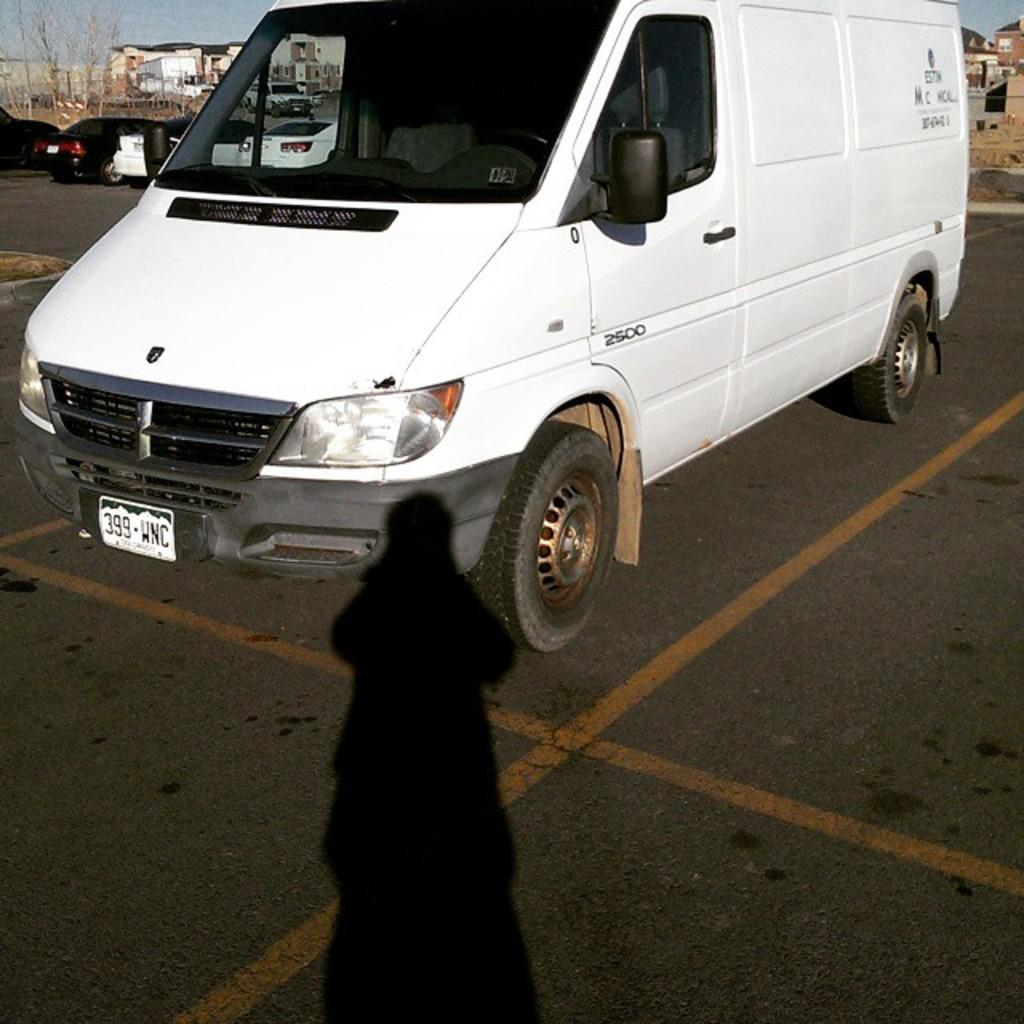Provide a one-sentence caption for the provided image. A white van is parked in a parking lot and says 2500 on the driver's door. 